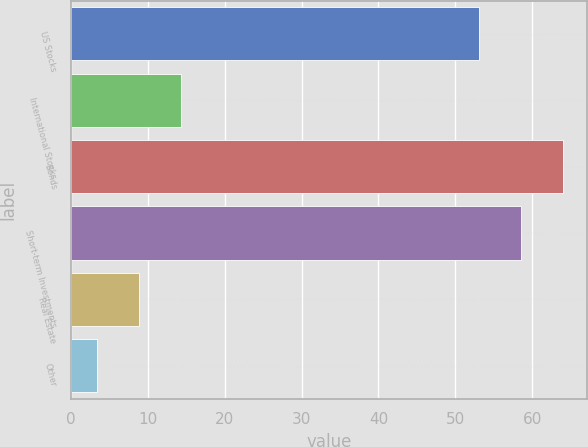<chart> <loc_0><loc_0><loc_500><loc_500><bar_chart><fcel>US Stocks<fcel>International Stocks<fcel>Bonds<fcel>Short-term Investments<fcel>Real Estate<fcel>Other<nl><fcel>53<fcel>14.32<fcel>63.92<fcel>58.46<fcel>8.86<fcel>3.4<nl></chart> 